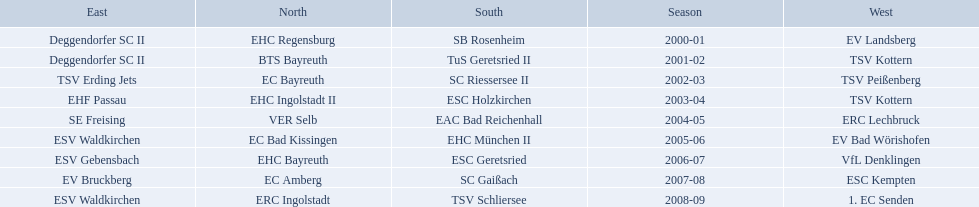Which teams won the north in their respective years? 2000-01, EHC Regensburg, BTS Bayreuth, EC Bayreuth, EHC Ingolstadt II, VER Selb, EC Bad Kissingen, EHC Bayreuth, EC Amberg, ERC Ingolstadt. Which one only won in 2000-01? EHC Regensburg. 